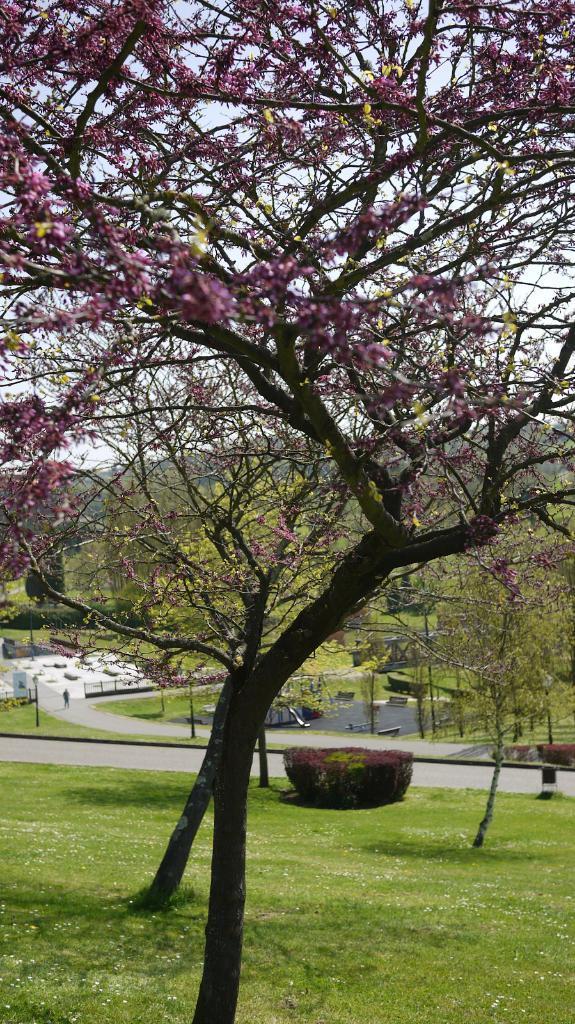In one or two sentences, can you explain what this image depicts? In this picture I can observe a tree. There are purple color leaves to this tree. There is some grass on the ground. In the background there are some trees and I can observe a road. There is a sky in the background. 